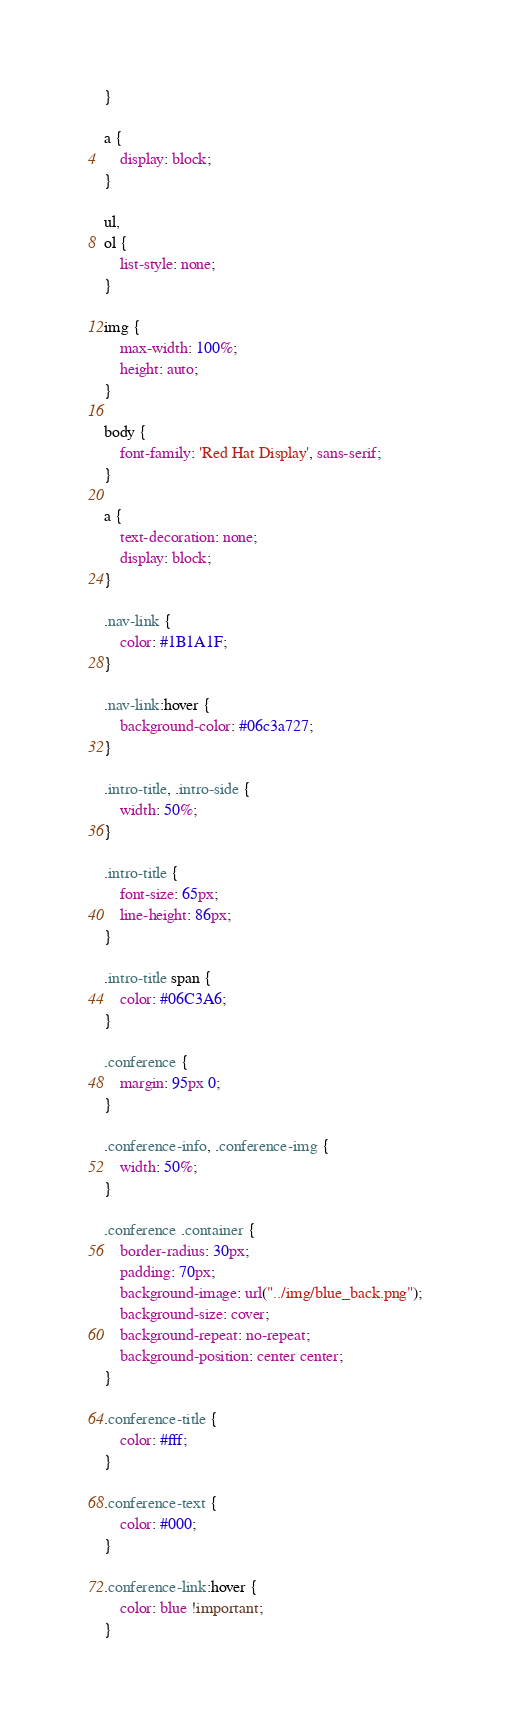Convert code to text. <code><loc_0><loc_0><loc_500><loc_500><_CSS_>}

a {
    display: block;
}

ul,
ol {
    list-style: none;
}

img {
    max-width: 100%;
    height: auto;
}

body {
    font-family: 'Red Hat Display', sans-serif;
}

a {
    text-decoration: none;
    display: block;
}

.nav-link {
    color: #1B1A1F;
}

.nav-link:hover {
    background-color: #06c3a727;
}

.intro-title, .intro-side {
    width: 50%;
}

.intro-title {
    font-size: 65px;
    line-height: 86px;
}

.intro-title span {
    color: #06C3A6;
}

.conference {
    margin: 95px 0;
}

.conference-info, .conference-img {
    width: 50%; 
}

.conference .container {
    border-radius: 30px;
    padding: 70px;
    background-image: url("../img/blue_back.png");
    background-size: cover;
    background-repeat: no-repeat;
    background-position: center center;
}

.conference-title {
    color: #fff;
}

.conference-text {
    color: #000;
}

.conference-link:hover {
    color: blue !important;
}</code> 